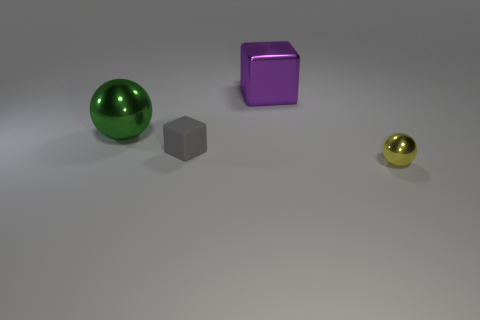Is there any other thing that has the same shape as the small shiny thing?
Offer a very short reply. Yes. Is the number of green metal balls in front of the tiny yellow metallic object greater than the number of purple metallic things that are left of the tiny gray block?
Keep it short and to the point. No. There is a shiny ball right of the shiny object that is to the left of the large object that is behind the green metal sphere; what size is it?
Offer a terse response. Small. Are the large green object and the block that is behind the gray thing made of the same material?
Your response must be concise. Yes. Do the gray rubber object and the big purple thing have the same shape?
Your answer should be very brief. Yes. How many other things are the same material as the small block?
Provide a succinct answer. 0. How many yellow metal things are the same shape as the small matte thing?
Your answer should be compact. 0. What color is the object that is both to the left of the large purple block and to the right of the green sphere?
Give a very brief answer. Gray. What number of large blocks are there?
Your answer should be compact. 1. Does the purple metallic object have the same size as the gray block?
Give a very brief answer. No. 